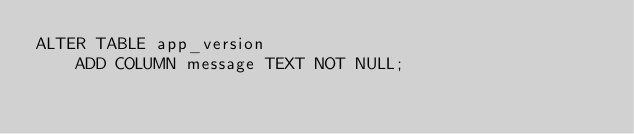Convert code to text. <code><loc_0><loc_0><loc_500><loc_500><_SQL_>ALTER TABLE app_version
	ADD COLUMN message TEXT NOT NULL;</code> 